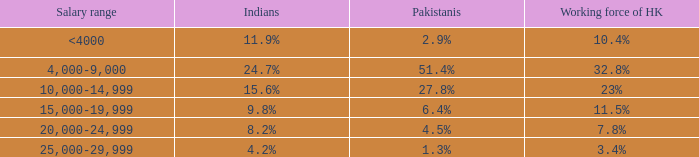If the nepalese population is 3 23%. 